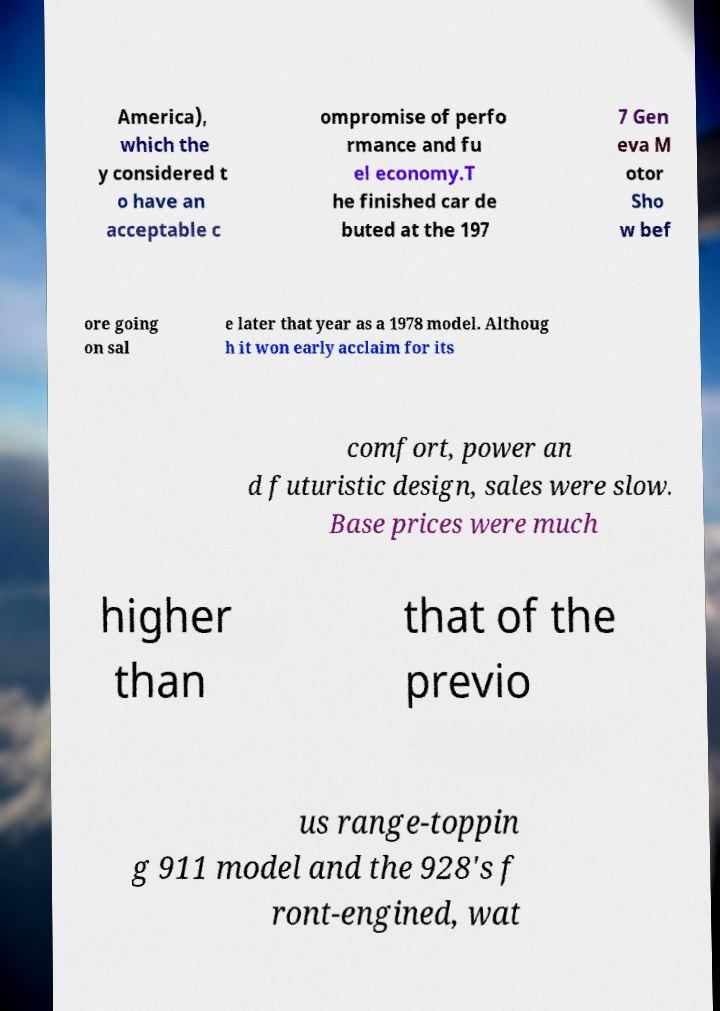There's text embedded in this image that I need extracted. Can you transcribe it verbatim? America), which the y considered t o have an acceptable c ompromise of perfo rmance and fu el economy.T he finished car de buted at the 197 7 Gen eva M otor Sho w bef ore going on sal e later that year as a 1978 model. Althoug h it won early acclaim for its comfort, power an d futuristic design, sales were slow. Base prices were much higher than that of the previo us range-toppin g 911 model and the 928's f ront-engined, wat 